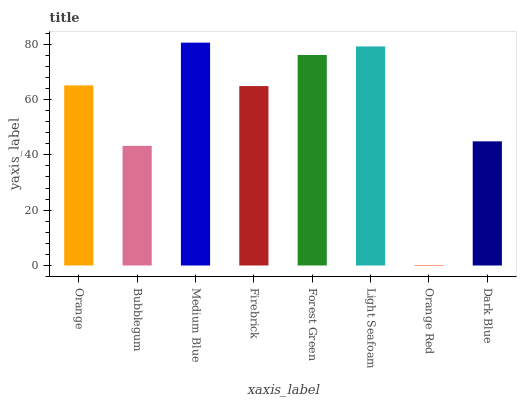Is Orange Red the minimum?
Answer yes or no. Yes. Is Medium Blue the maximum?
Answer yes or no. Yes. Is Bubblegum the minimum?
Answer yes or no. No. Is Bubblegum the maximum?
Answer yes or no. No. Is Orange greater than Bubblegum?
Answer yes or no. Yes. Is Bubblegum less than Orange?
Answer yes or no. Yes. Is Bubblegum greater than Orange?
Answer yes or no. No. Is Orange less than Bubblegum?
Answer yes or no. No. Is Orange the high median?
Answer yes or no. Yes. Is Firebrick the low median?
Answer yes or no. Yes. Is Light Seafoam the high median?
Answer yes or no. No. Is Orange the low median?
Answer yes or no. No. 